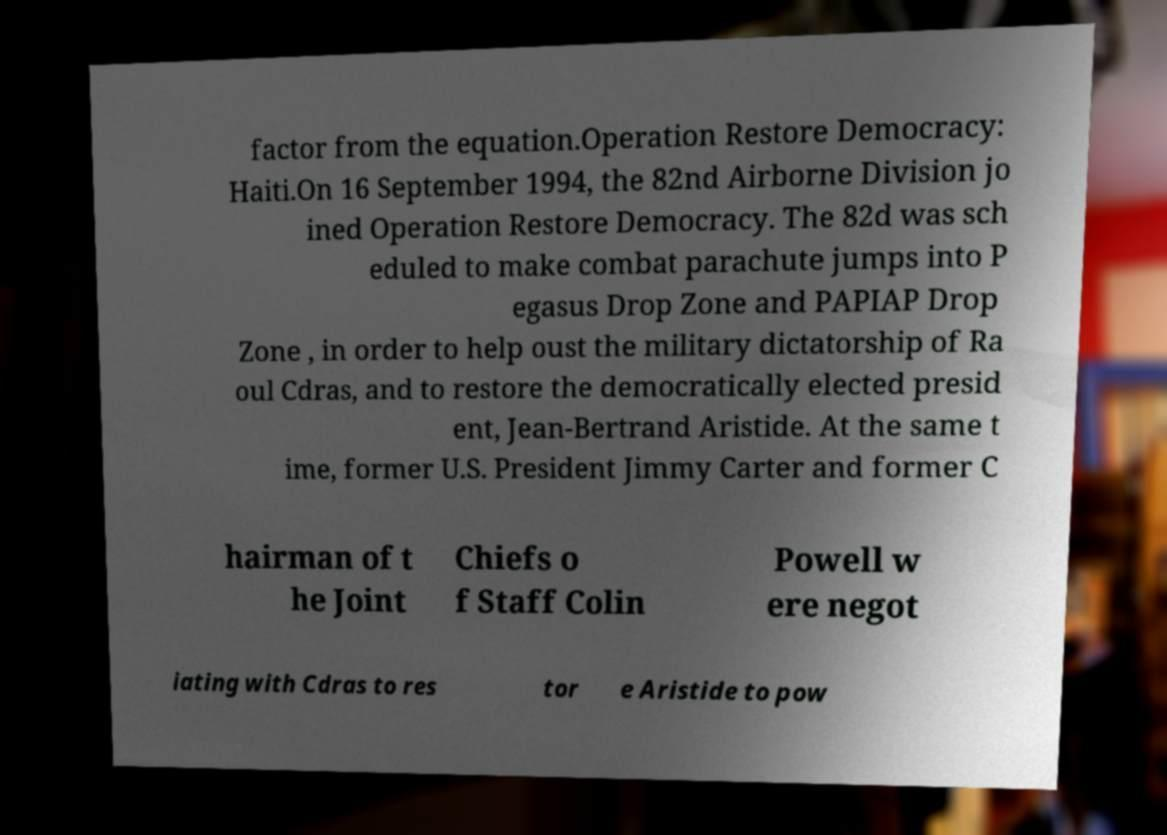For documentation purposes, I need the text within this image transcribed. Could you provide that? factor from the equation.Operation Restore Democracy: Haiti.On 16 September 1994, the 82nd Airborne Division jo ined Operation Restore Democracy. The 82d was sch eduled to make combat parachute jumps into P egasus Drop Zone and PAPIAP Drop Zone , in order to help oust the military dictatorship of Ra oul Cdras, and to restore the democratically elected presid ent, Jean-Bertrand Aristide. At the same t ime, former U.S. President Jimmy Carter and former C hairman of t he Joint Chiefs o f Staff Colin Powell w ere negot iating with Cdras to res tor e Aristide to pow 